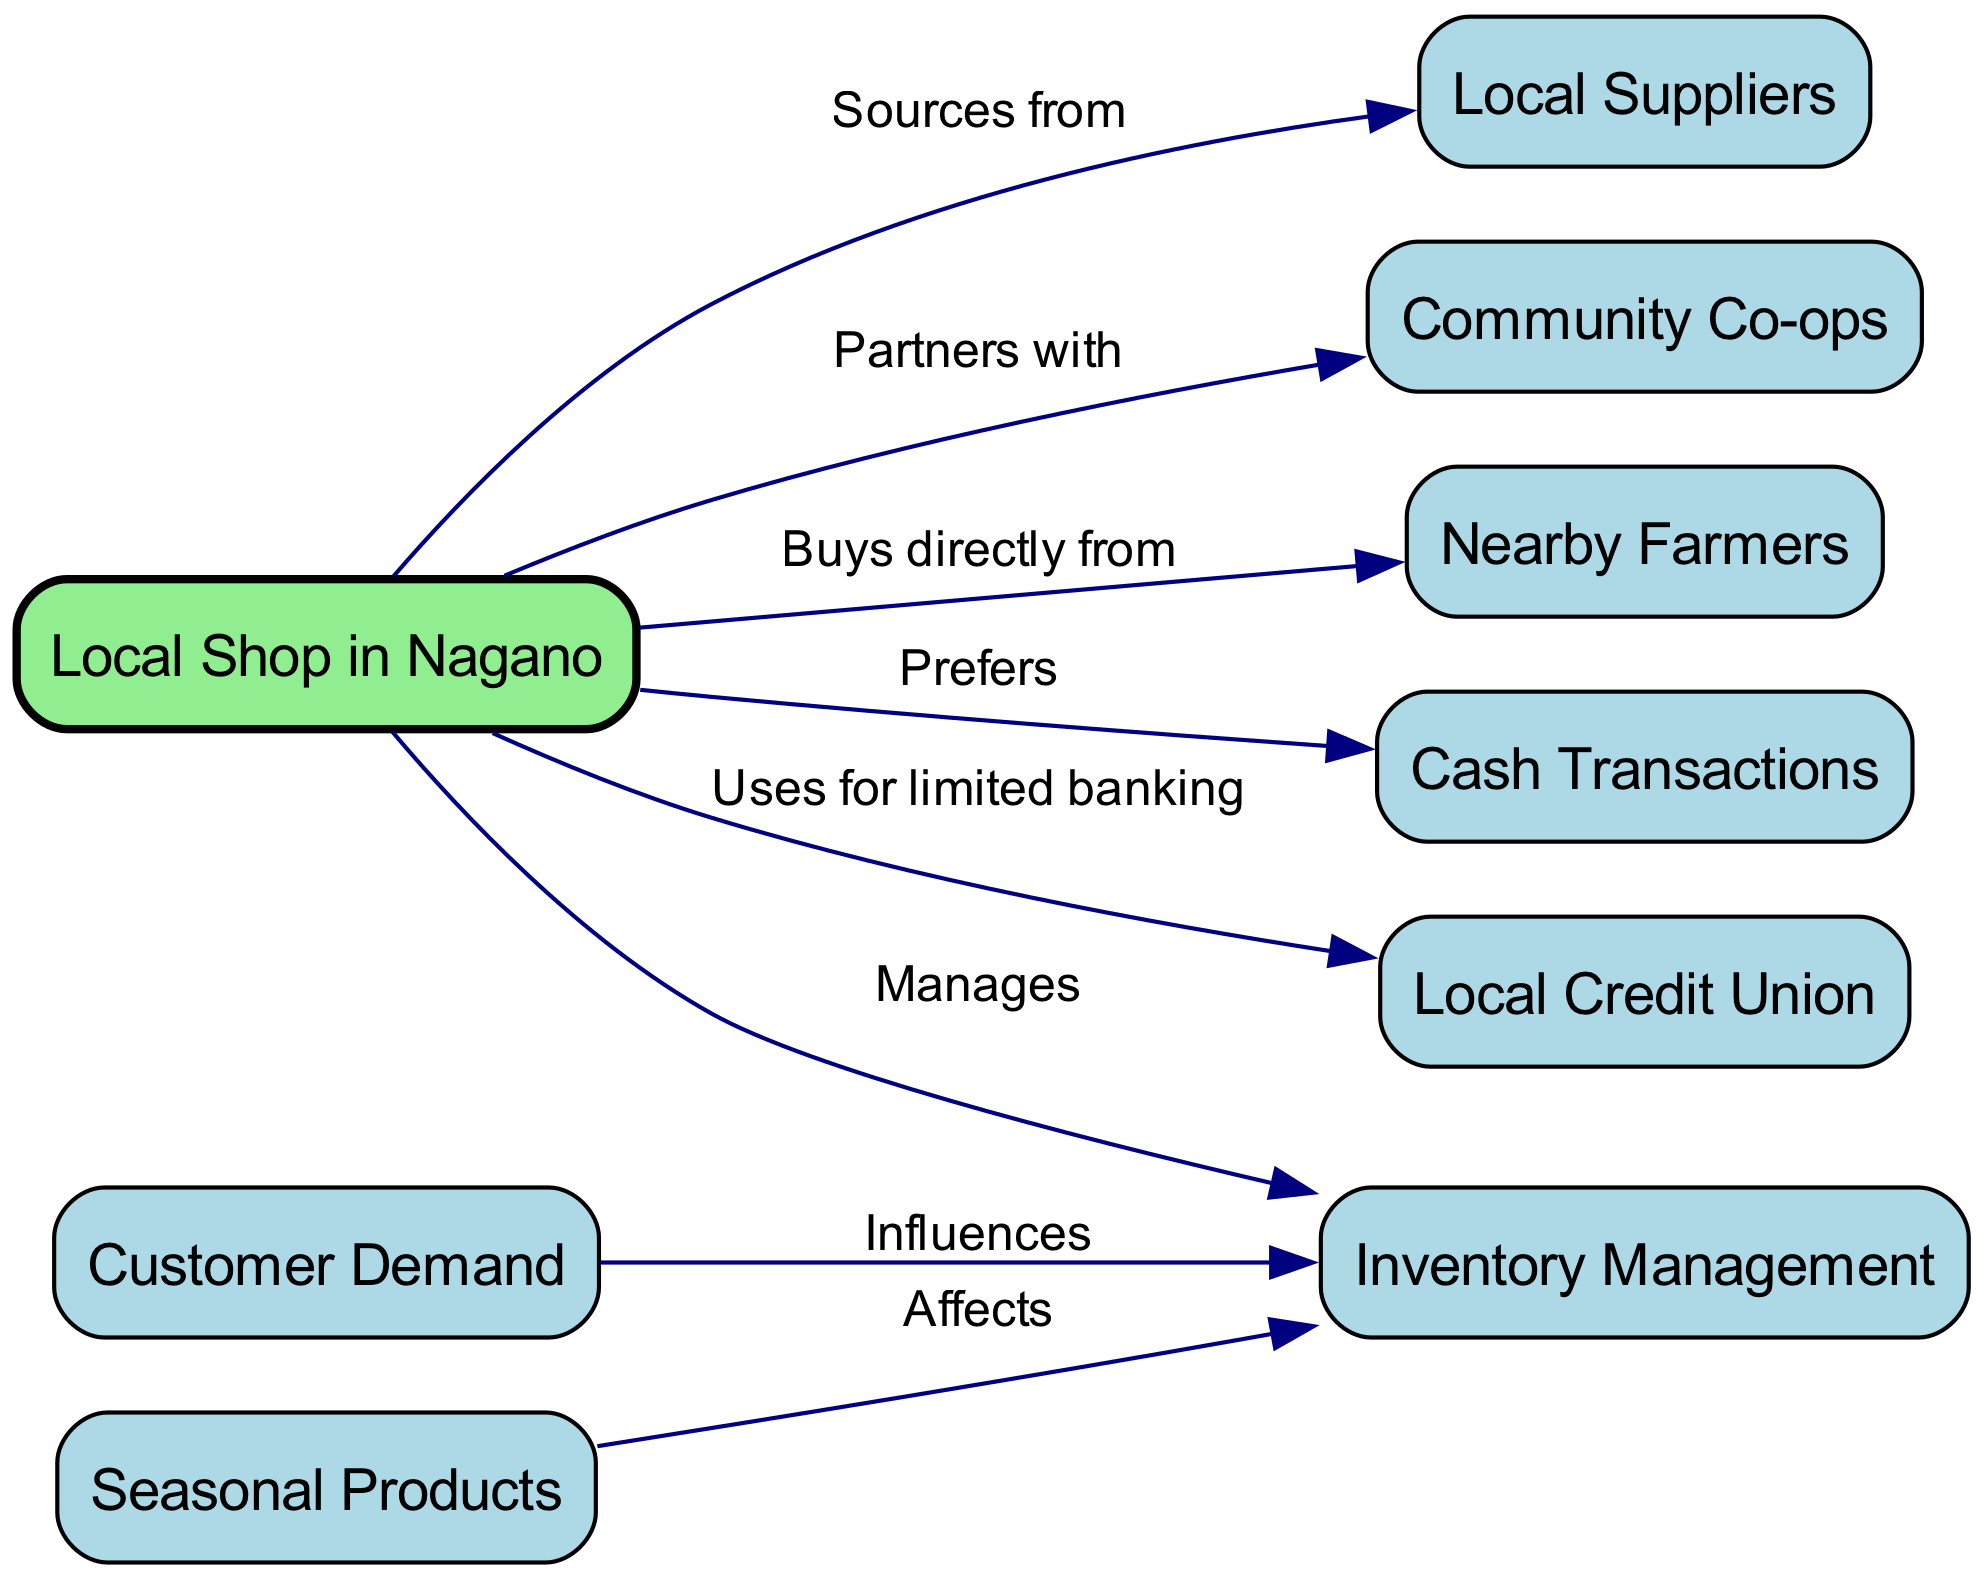What is the main node in the diagram? The main node in the diagram is labeled "Local Shop in Nagano" as it is the central element from which all other nodes connect. It is also highlighted in light green, showing its significance in the concept map.
Answer: Local Shop in Nagano How many nodes are present in total? The diagram contains a total of nine nodes, which can be counted from the list provided in the data under the "nodes" section.
Answer: Nine What relationship exists between the "Local Shop in Nagano" and "Local Suppliers"? The relationship is labeled "Sources from," indicating that the Local Shop in Nagano obtains its products from Local Suppliers. This connection is represented with an arrow pointing from the shop to the suppliers.
Answer: Sources from Which node influences "Inventory Management"? The node that influences "Inventory Management" is "Customer Demand," as indicated by the directed edge connecting the two, meaning that customer preferences have a direct impact on how inventory is managed.
Answer: Customer Demand What affects "Inventory Management"? "Seasonal Products" affects "Inventory Management," as expressed in the diagram by a directed edge pointing from the Seasonal Products node to the Inventory Management node, denoting that variability in products based on seasons plays a role in how inventory is maintained.
Answer: Seasonal Products What does the "Local Shop in Nagano" prefer as a transaction method? The Local Shop in Nagano prefers "Cash Transactions," which is indicated in the diagram by a direct edge labeled "Prefers" connecting the shop to the cash transactions node.
Answer: Cash Transactions Which two nodes are partnered with the "Local Shop in Nagano"? The "Local Shop in Nagano" is partnered with "Community Co-ops" and it also sources from "Local Suppliers," as shown by the edges connecting the shop to each of these nodes.
Answer: Community Co-ops and Local Suppliers What type of financial institution does the "Local Shop in Nagano" use? The Local Shop in Nagano uses a "Local Credit Union" for limited banking, as indicated by the edge connecting the shop to the credit union node in the diagram.
Answer: Local Credit Union How does "Customer Demand" relate to "Local Shop in Nagano"? "Customer Demand" influences "Inventory Management," which is managed directly by the "Local Shop in Nagano," establishing an indirect relation where the shop must adapt its inventory based on customer desires.
Answer: Indirect influence through Inventory Management 